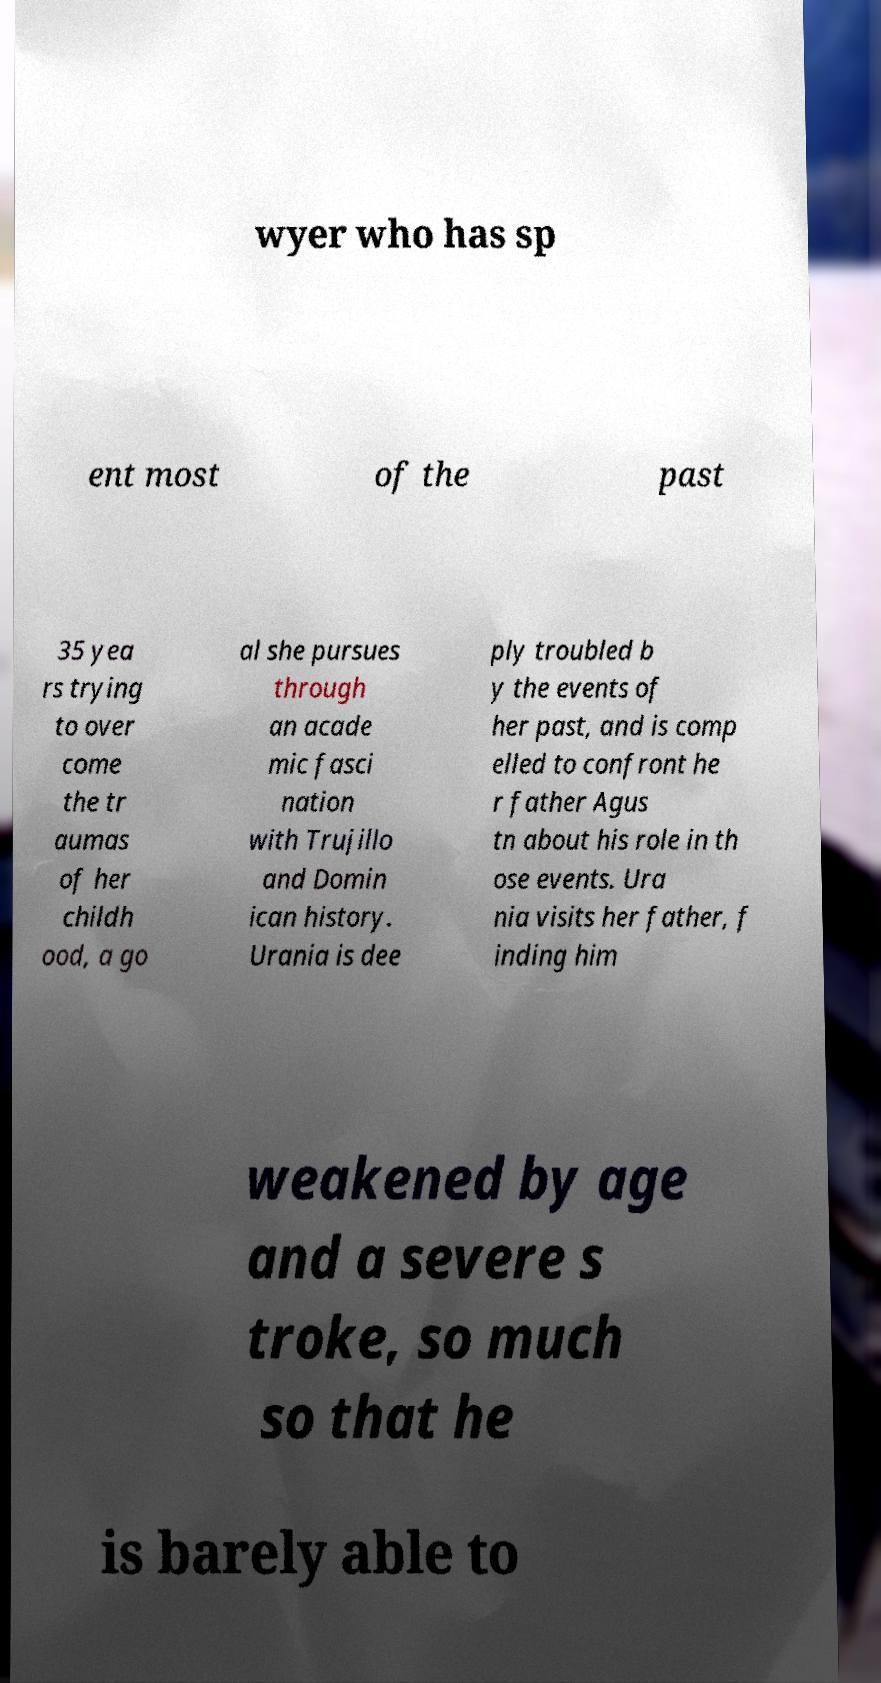Please identify and transcribe the text found in this image. wyer who has sp ent most of the past 35 yea rs trying to over come the tr aumas of her childh ood, a go al she pursues through an acade mic fasci nation with Trujillo and Domin ican history. Urania is dee ply troubled b y the events of her past, and is comp elled to confront he r father Agus tn about his role in th ose events. Ura nia visits her father, f inding him weakened by age and a severe s troke, so much so that he is barely able to 